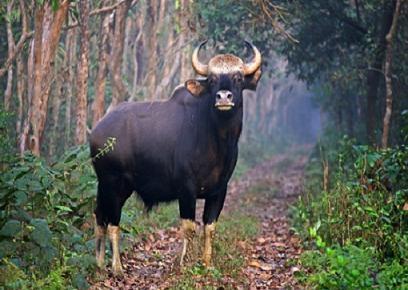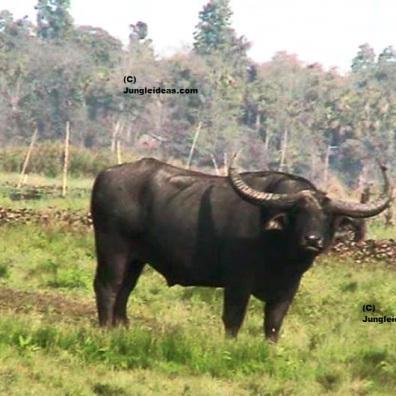The first image is the image on the left, the second image is the image on the right. Considering the images on both sides, is "Left image contains one dark water buffalo with light coloring on its lower legs, and its head turned to look directly at the camera." valid? Answer yes or no. Yes. The first image is the image on the left, the second image is the image on the right. Considering the images on both sides, is "At least one of the images contains more than one water buffalo." valid? Answer yes or no. No. 